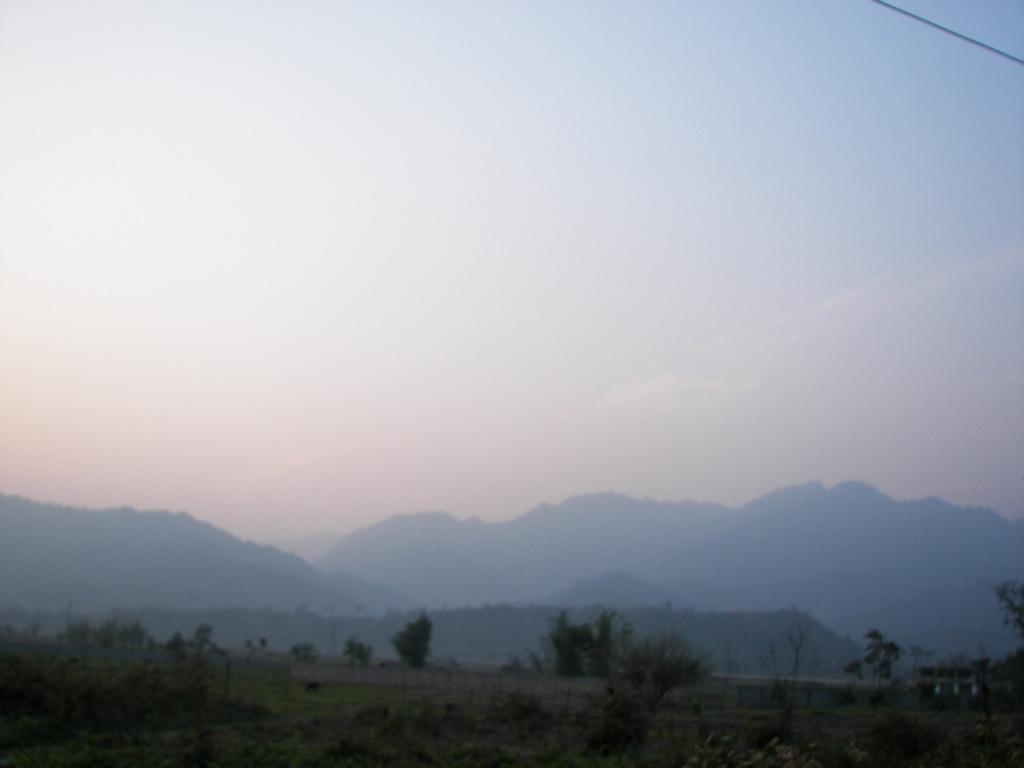Describe this image in one or two sentences. In this image we can see the plants and trees. And we can see the hills and at the top we can see the sky. 